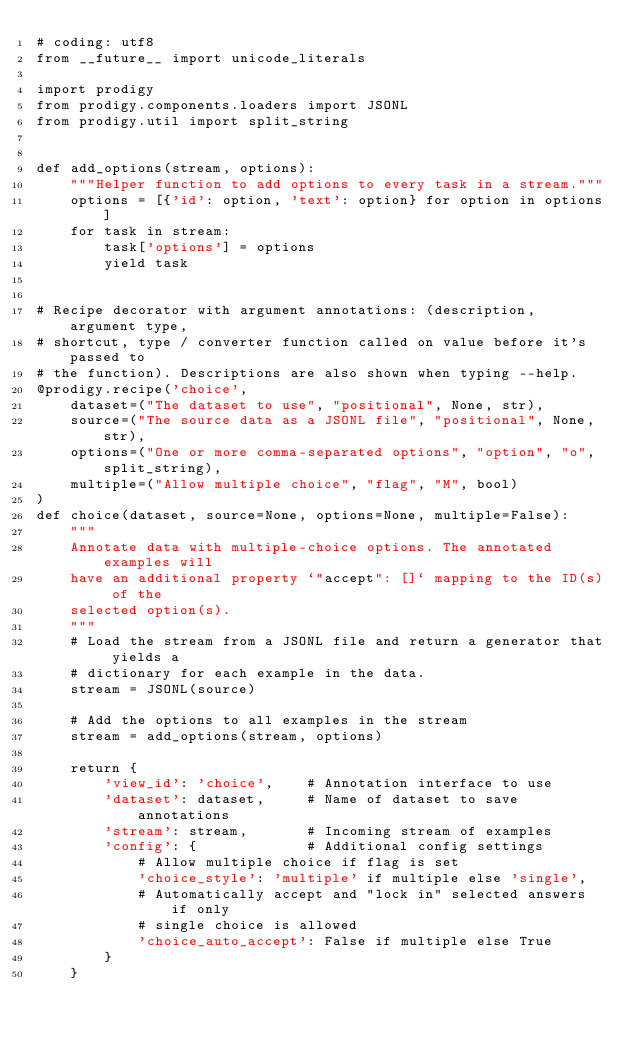<code> <loc_0><loc_0><loc_500><loc_500><_Python_># coding: utf8
from __future__ import unicode_literals

import prodigy
from prodigy.components.loaders import JSONL
from prodigy.util import split_string


def add_options(stream, options):
    """Helper function to add options to every task in a stream."""
    options = [{'id': option, 'text': option} for option in options]
    for task in stream:
        task['options'] = options
        yield task


# Recipe decorator with argument annotations: (description, argument type,
# shortcut, type / converter function called on value before it's passed to
# the function). Descriptions are also shown when typing --help.
@prodigy.recipe('choice',
    dataset=("The dataset to use", "positional", None, str),
    source=("The source data as a JSONL file", "positional", None, str),
    options=("One or more comma-separated options", "option", "o", split_string),
    multiple=("Allow multiple choice", "flag", "M", bool)
)
def choice(dataset, source=None, options=None, multiple=False):
    """
    Annotate data with multiple-choice options. The annotated examples will
    have an additional property `"accept": []` mapping to the ID(s) of the
    selected option(s).
    """
    # Load the stream from a JSONL file and return a generator that yields a
    # dictionary for each example in the data.
    stream = JSONL(source)

    # Add the options to all examples in the stream
    stream = add_options(stream, options)

    return {
        'view_id': 'choice',    # Annotation interface to use
        'dataset': dataset,     # Name of dataset to save annotations
        'stream': stream,       # Incoming stream of examples
        'config': {             # Additional config settings
            # Allow multiple choice if flag is set
            'choice_style': 'multiple' if multiple else 'single',
            # Automatically accept and "lock in" selected answers if only
            # single choice is allowed
            'choice_auto_accept': False if multiple else True
        }
    }
</code> 